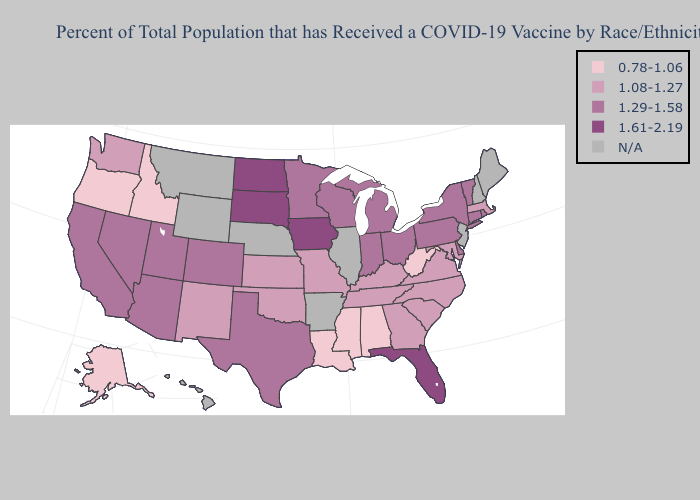Among the states that border California , does Arizona have the lowest value?
Be succinct. No. Does Massachusetts have the highest value in the Northeast?
Short answer required. No. Name the states that have a value in the range 1.61-2.19?
Quick response, please. Florida, Iowa, North Dakota, South Dakota. Among the states that border Nevada , which have the highest value?
Be succinct. Arizona, California, Utah. What is the value of Iowa?
Be succinct. 1.61-2.19. What is the highest value in the Northeast ?
Give a very brief answer. 1.29-1.58. Does California have the lowest value in the USA?
Keep it brief. No. Among the states that border Tennessee , which have the highest value?
Write a very short answer. Georgia, Kentucky, Missouri, North Carolina, Virginia. Name the states that have a value in the range 1.61-2.19?
Write a very short answer. Florida, Iowa, North Dakota, South Dakota. Name the states that have a value in the range 1.08-1.27?
Be succinct. Georgia, Kansas, Kentucky, Maryland, Massachusetts, Missouri, New Mexico, North Carolina, Oklahoma, South Carolina, Tennessee, Virginia, Washington. What is the value of Maryland?
Give a very brief answer. 1.08-1.27. What is the lowest value in the USA?
Quick response, please. 0.78-1.06. Name the states that have a value in the range 1.61-2.19?
Give a very brief answer. Florida, Iowa, North Dakota, South Dakota. What is the lowest value in the Northeast?
Quick response, please. 1.08-1.27. Is the legend a continuous bar?
Give a very brief answer. No. 